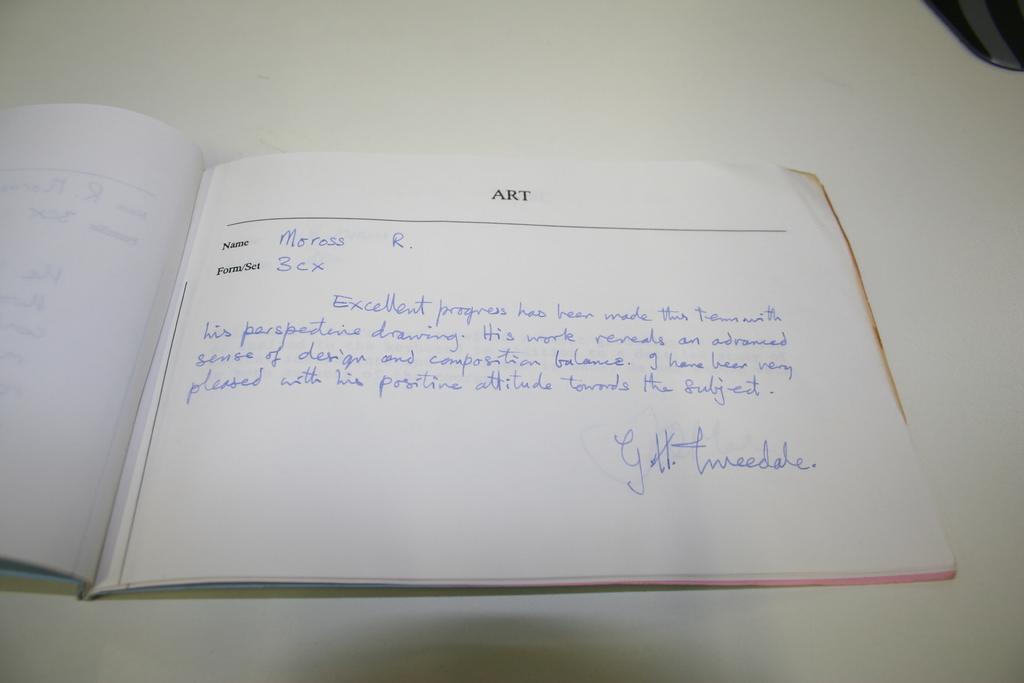Which school subject is the written evaluation about?
Your answer should be compact. Art. Who's name is on the paper?
Give a very brief answer. Moross r. 